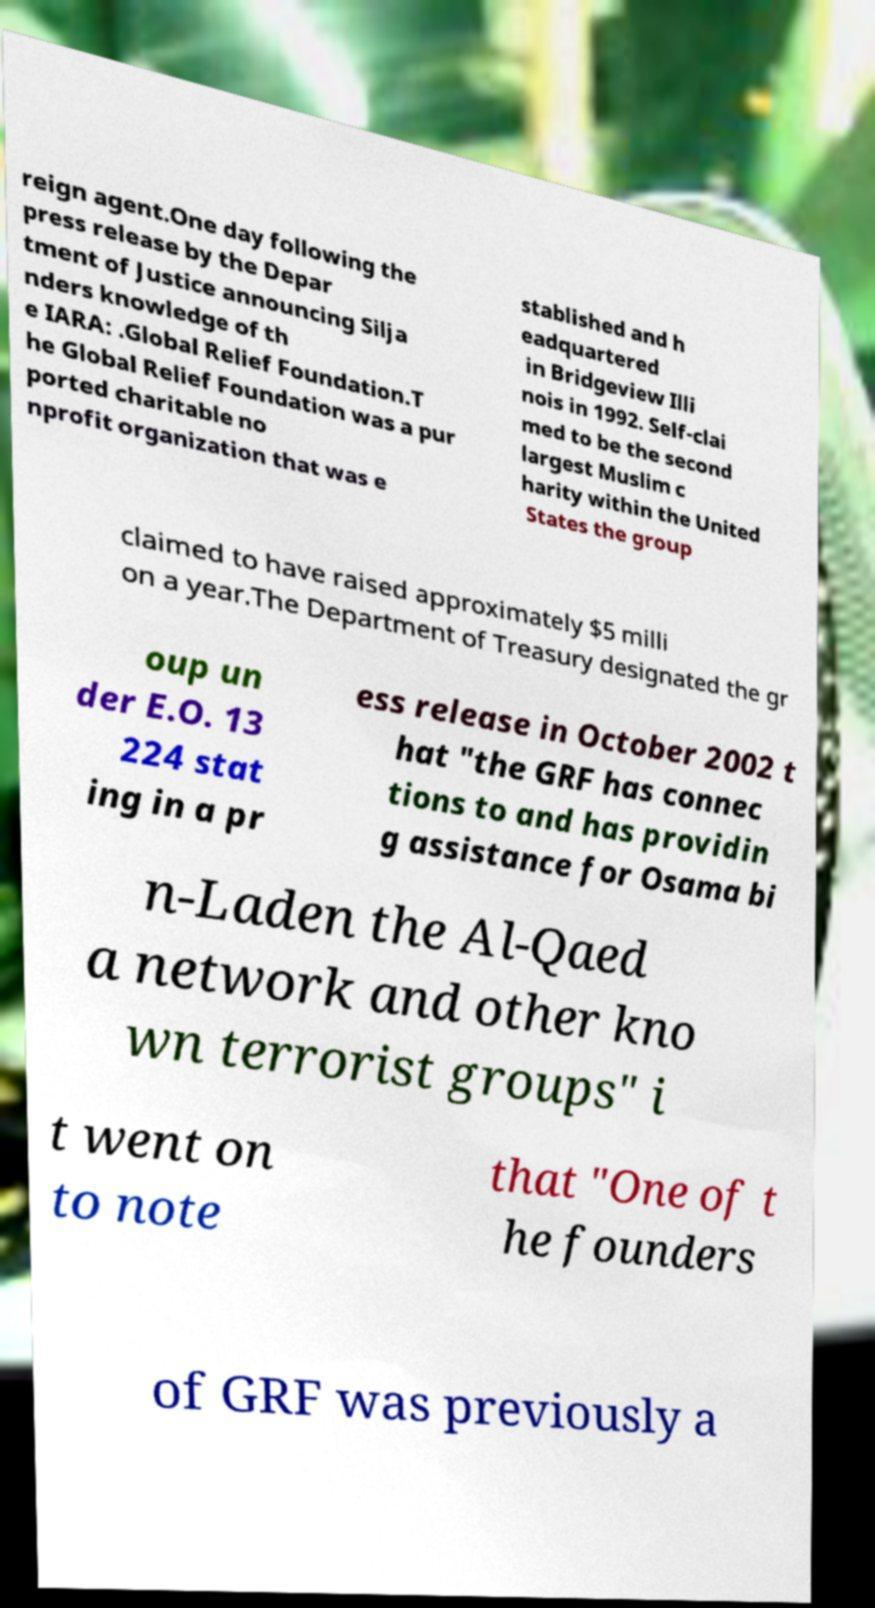Could you extract and type out the text from this image? reign agent.One day following the press release by the Depar tment of Justice announcing Silja nders knowledge of th e IARA: .Global Relief Foundation.T he Global Relief Foundation was a pur ported charitable no nprofit organization that was e stablished and h eadquartered in Bridgeview Illi nois in 1992. Self-clai med to be the second largest Muslim c harity within the United States the group claimed to have raised approximately $5 milli on a year.The Department of Treasury designated the gr oup un der E.O. 13 224 stat ing in a pr ess release in October 2002 t hat "the GRF has connec tions to and has providin g assistance for Osama bi n-Laden the Al-Qaed a network and other kno wn terrorist groups" i t went on to note that "One of t he founders of GRF was previously a 